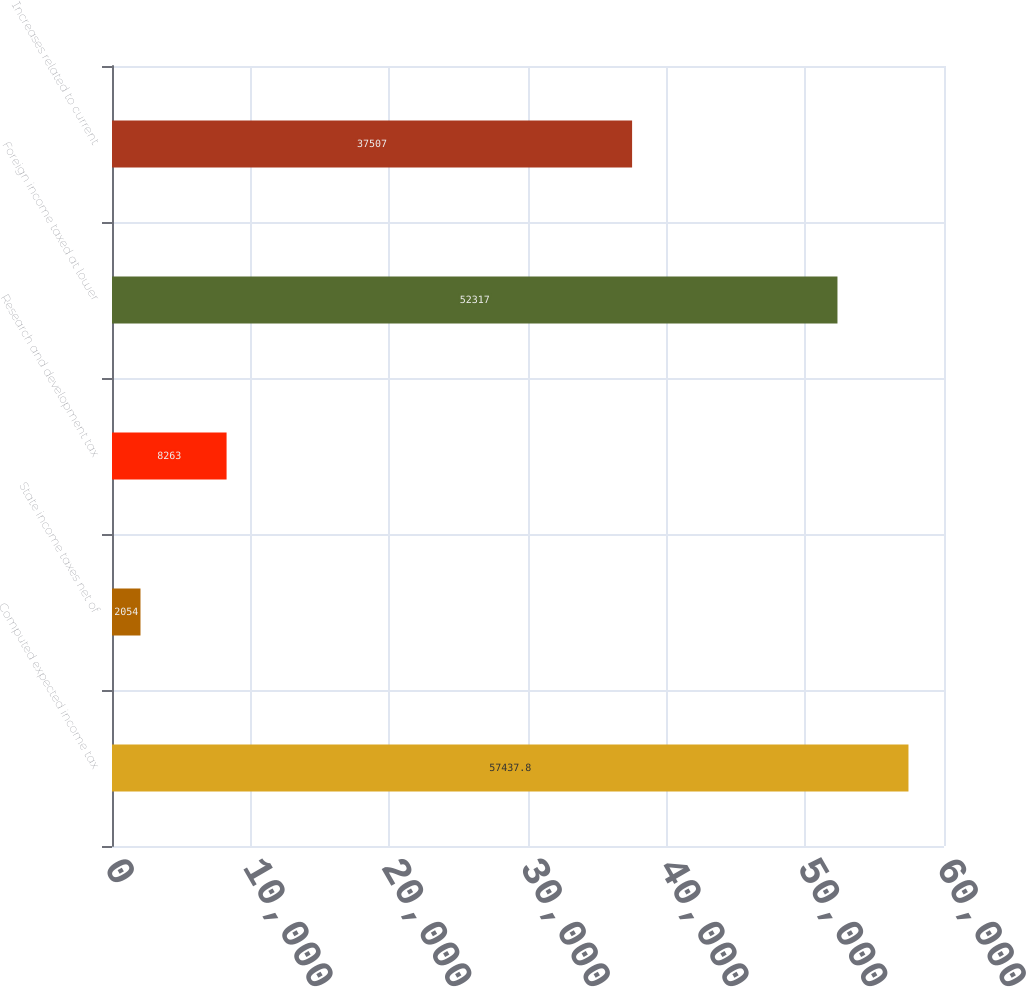Convert chart. <chart><loc_0><loc_0><loc_500><loc_500><bar_chart><fcel>Computed expected income tax<fcel>State income taxes net of<fcel>Research and development tax<fcel>Foreign income taxed at lower<fcel>Increases related to current<nl><fcel>57437.8<fcel>2054<fcel>8263<fcel>52317<fcel>37507<nl></chart> 